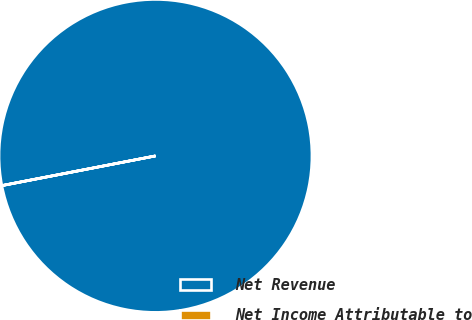Convert chart. <chart><loc_0><loc_0><loc_500><loc_500><pie_chart><fcel>Net Revenue<fcel>Net Income Attributable to<nl><fcel>99.99%<fcel>0.01%<nl></chart> 